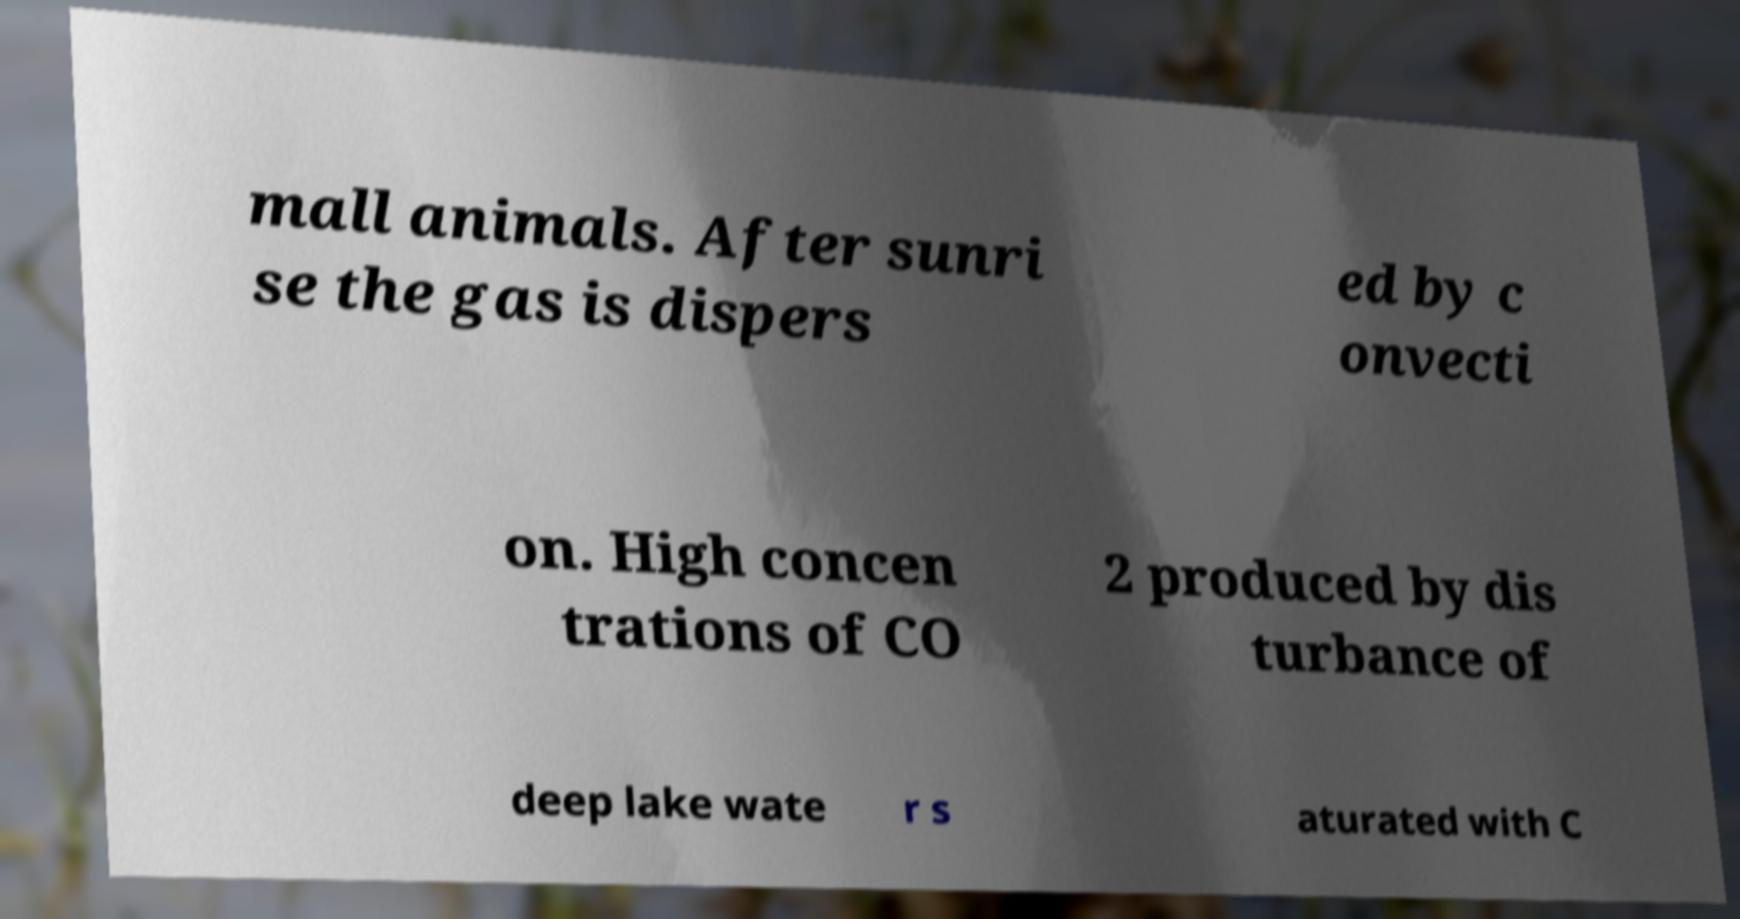Could you assist in decoding the text presented in this image and type it out clearly? mall animals. After sunri se the gas is dispers ed by c onvecti on. High concen trations of CO 2 produced by dis turbance of deep lake wate r s aturated with C 